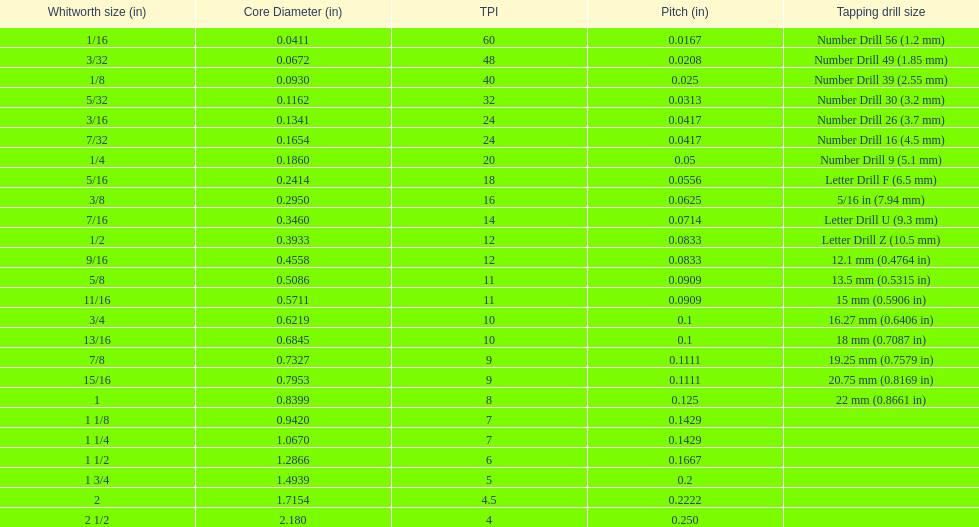What is the core diameter of the first 1/8 whitworth size (in)? 0.0930. 